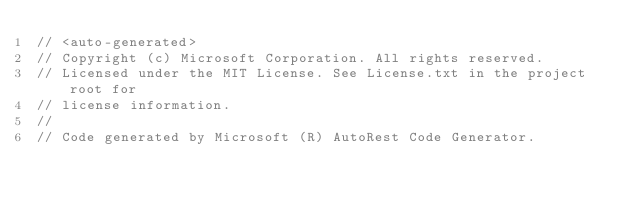Convert code to text. <code><loc_0><loc_0><loc_500><loc_500><_C#_>// <auto-generated>
// Copyright (c) Microsoft Corporation. All rights reserved.
// Licensed under the MIT License. See License.txt in the project root for
// license information.
//
// Code generated by Microsoft (R) AutoRest Code Generator.</code> 